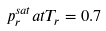Convert formula to latex. <formula><loc_0><loc_0><loc_500><loc_500>p _ { r } ^ { s a t } a t T _ { r } = 0 . 7</formula> 